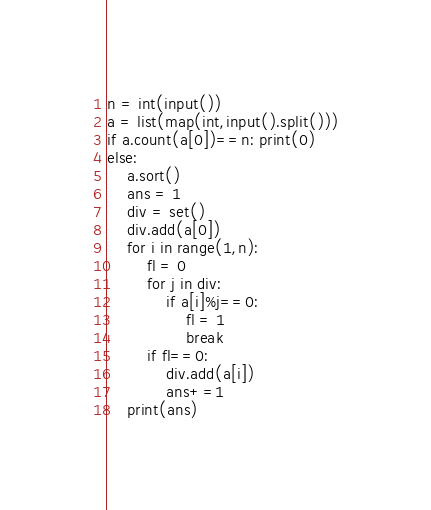Convert code to text. <code><loc_0><loc_0><loc_500><loc_500><_Python_>n = int(input())
a = list(map(int,input().split()))
if a.count(a[0])==n: print(0)
else:
    a.sort()
    ans = 1
    div = set()
    div.add(a[0])
    for i in range(1,n):
        fl = 0
        for j in div:
            if a[i]%j==0:
                fl = 1
                break
        if fl==0:
            div.add(a[i])
            ans+=1
    print(ans)</code> 